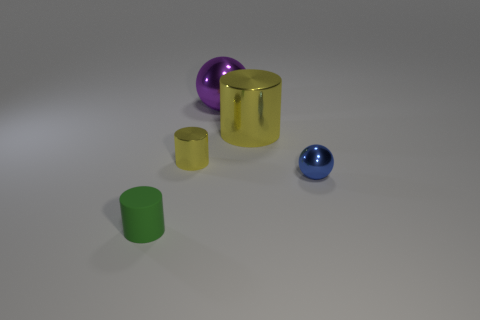What is the size of the other cylinder that is the same color as the big cylinder?
Your answer should be very brief. Small. There is a shiny cylinder that is in front of the big yellow thing; is its color the same as the cylinder that is on the right side of the big purple sphere?
Make the answer very short. Yes. Is there anything else that is made of the same material as the small green thing?
Give a very brief answer. No. Are there more tiny cylinders that are behind the blue object than green things?
Provide a short and direct response. No. Are there any tiny objects that are left of the yellow metallic cylinder that is behind the tiny yellow metal cylinder that is in front of the purple object?
Offer a very short reply. Yes. Are there any small things behind the tiny green object?
Your response must be concise. Yes. What number of shiny things have the same color as the big cylinder?
Keep it short and to the point. 1. What size is the other cylinder that is made of the same material as the large yellow cylinder?
Offer a terse response. Small. There is a shiny object that is behind the yellow metal thing that is right of the tiny cylinder that is behind the green cylinder; what size is it?
Provide a succinct answer. Large. There is a yellow object left of the large yellow metallic thing; what size is it?
Provide a succinct answer. Small. 